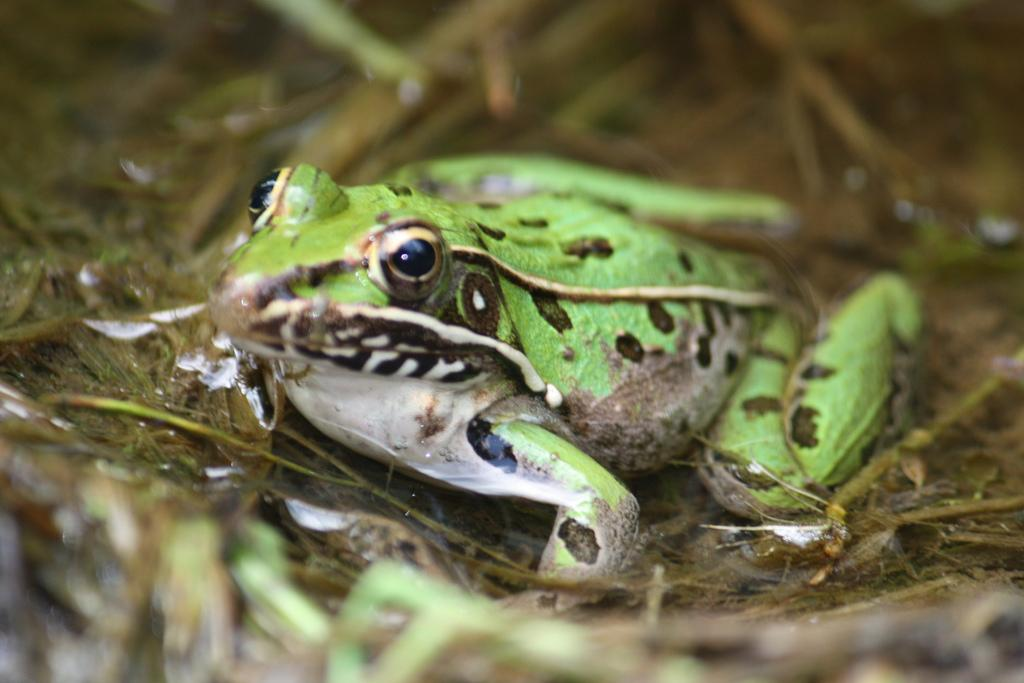What animal is present in the image? There is a frog in the image. Where is the frog located? The frog is in the water. What type of vegetation can be seen at the bottom of the image? There is grass at the bottom of the image. What type of spark can be seen coming from the frog's mouth in the image? There is no spark coming from the frog's mouth in the image. What kind of horn is attached to the frog in the image? There is no horn attached to the frog in the image. 